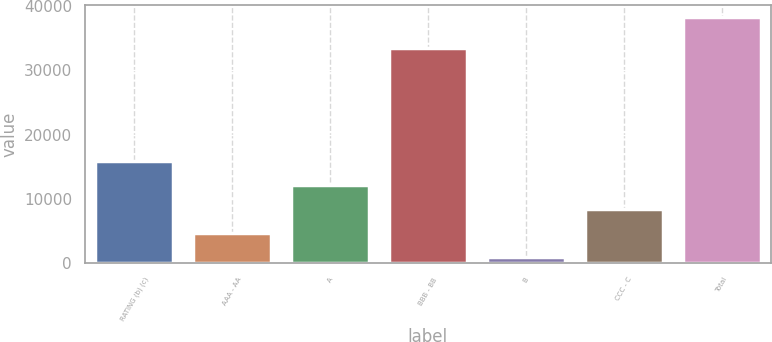Convert chart to OTSL. <chart><loc_0><loc_0><loc_500><loc_500><bar_chart><fcel>RATING (b) (c)<fcel>AAA - AA<fcel>A<fcel>BBB - BB<fcel>B<fcel>CCC - C<fcel>Total<nl><fcel>15901.6<fcel>4689.4<fcel>12164.2<fcel>33497<fcel>952<fcel>8426.8<fcel>38326<nl></chart> 